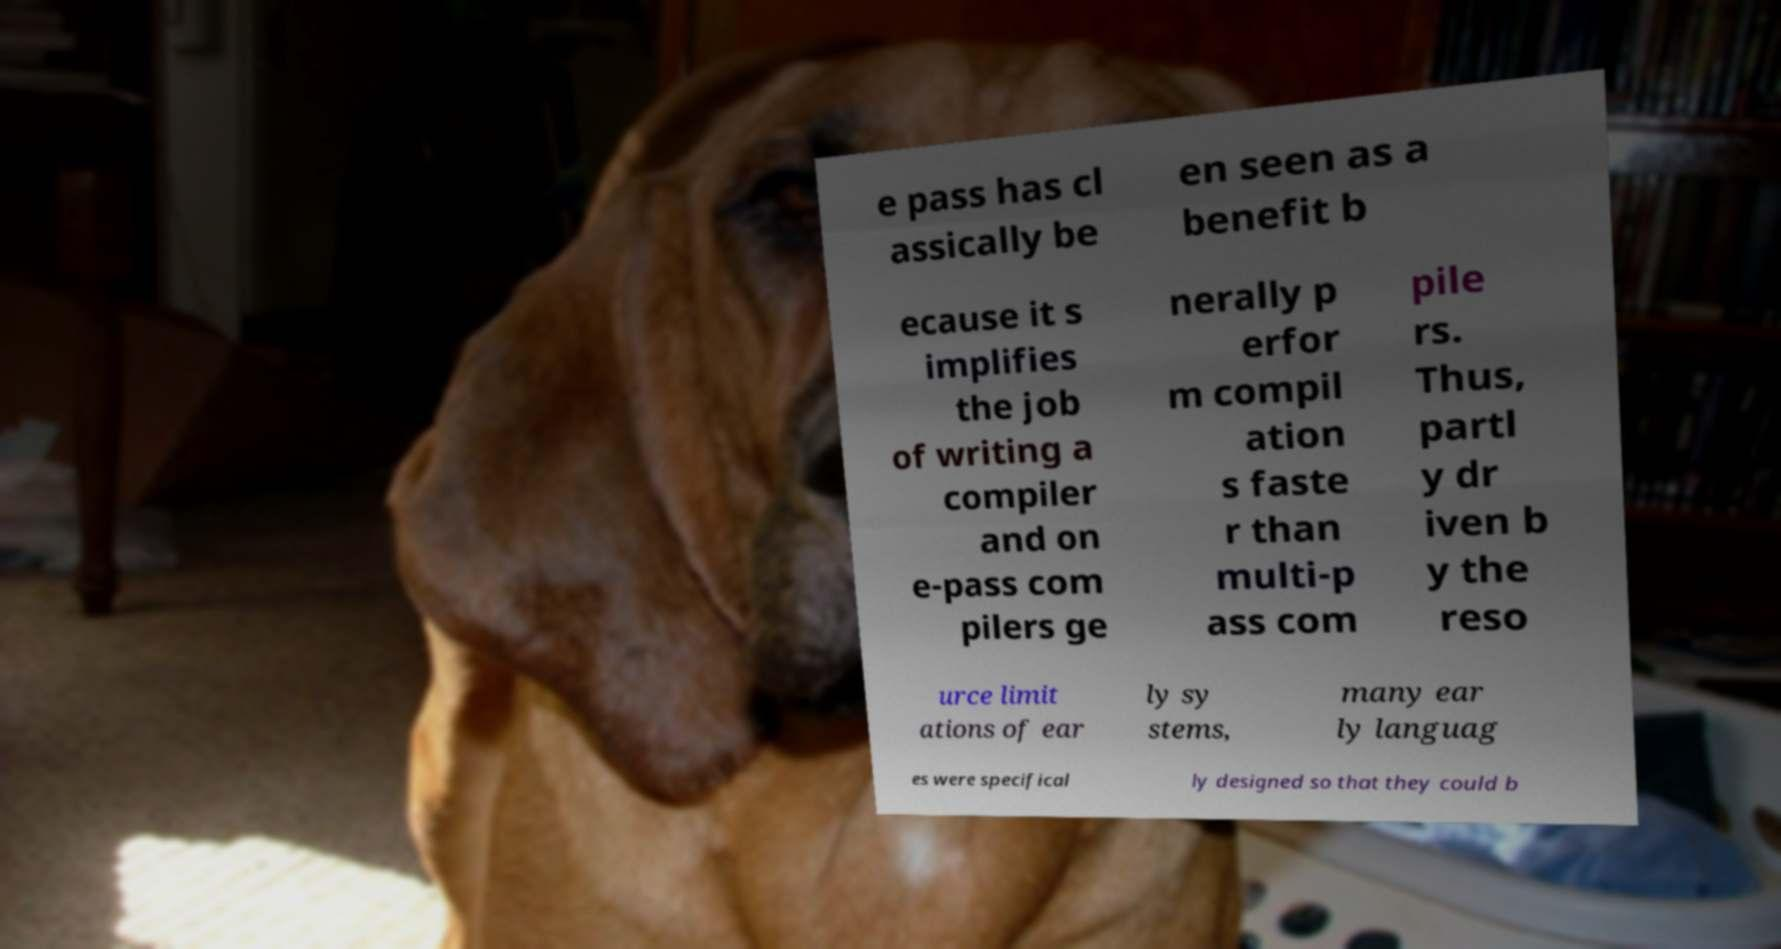There's text embedded in this image that I need extracted. Can you transcribe it verbatim? e pass has cl assically be en seen as a benefit b ecause it s implifies the job of writing a compiler and on e-pass com pilers ge nerally p erfor m compil ation s faste r than multi-p ass com pile rs. Thus, partl y dr iven b y the reso urce limit ations of ear ly sy stems, many ear ly languag es were specifical ly designed so that they could b 